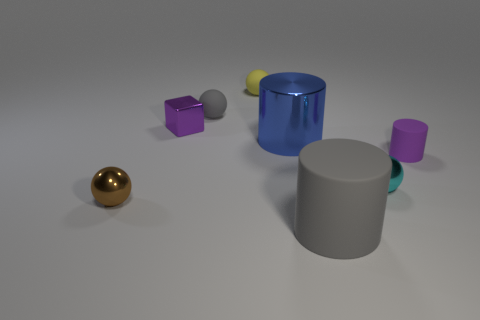Subtract all cylinders. How many objects are left? 5 Subtract 3 cylinders. How many cylinders are left? 0 Subtract all gray cylinders. Subtract all brown blocks. How many cylinders are left? 2 Subtract all gray spheres. How many blue cylinders are left? 1 Subtract all blue cylinders. Subtract all small cyan metal things. How many objects are left? 6 Add 4 small yellow balls. How many small yellow balls are left? 5 Add 8 yellow matte objects. How many yellow matte objects exist? 9 Add 2 large green metal blocks. How many objects exist? 10 Subtract all gray balls. How many balls are left? 3 Subtract all tiny cyan metallic balls. How many balls are left? 3 